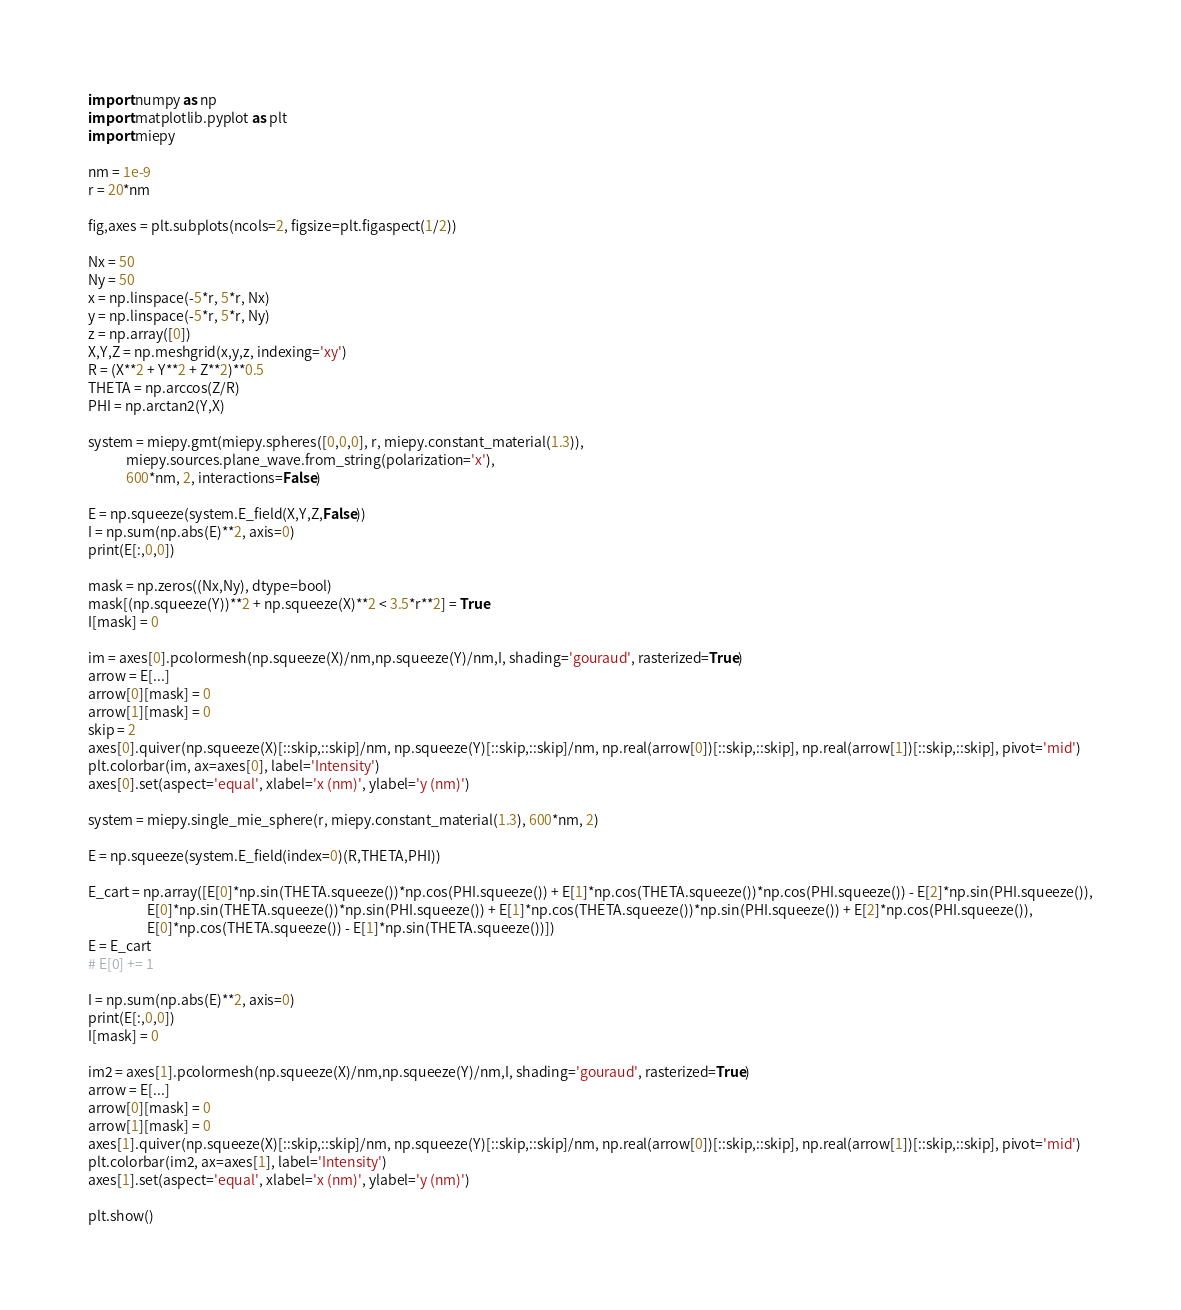<code> <loc_0><loc_0><loc_500><loc_500><_Python_>import numpy as np
import matplotlib.pyplot as plt
import miepy

nm = 1e-9
r = 20*nm

fig,axes = plt.subplots(ncols=2, figsize=plt.figaspect(1/2))

Nx = 50
Ny = 50
x = np.linspace(-5*r, 5*r, Nx)
y = np.linspace(-5*r, 5*r, Ny)
z = np.array([0])
X,Y,Z = np.meshgrid(x,y,z, indexing='xy') 
R = (X**2 + Y**2 + Z**2)**0.5
THETA = np.arccos(Z/R)
PHI = np.arctan2(Y,X)

system = miepy.gmt(miepy.spheres([0,0,0], r, miepy.constant_material(1.3)), 
            miepy.sources.plane_wave.from_string(polarization='x'),
            600*nm, 2, interactions=False)

E = np.squeeze(system.E_field(X,Y,Z,False))
I = np.sum(np.abs(E)**2, axis=0)
print(E[:,0,0])

mask = np.zeros((Nx,Ny), dtype=bool)
mask[(np.squeeze(Y))**2 + np.squeeze(X)**2 < 3.5*r**2] = True
I[mask] = 0

im = axes[0].pcolormesh(np.squeeze(X)/nm,np.squeeze(Y)/nm,I, shading='gouraud', rasterized=True)
arrow = E[...]
arrow[0][mask] = 0
arrow[1][mask] = 0
skip = 2
axes[0].quiver(np.squeeze(X)[::skip,::skip]/nm, np.squeeze(Y)[::skip,::skip]/nm, np.real(arrow[0])[::skip,::skip], np.real(arrow[1])[::skip,::skip], pivot='mid')
plt.colorbar(im, ax=axes[0], label='Intensity')
axes[0].set(aspect='equal', xlabel='x (nm)', ylabel='y (nm)')

system = miepy.single_mie_sphere(r, miepy.constant_material(1.3), 600*nm, 2)

E = np.squeeze(system.E_field(index=0)(R,THETA,PHI))

E_cart = np.array([E[0]*np.sin(THETA.squeeze())*np.cos(PHI.squeeze()) + E[1]*np.cos(THETA.squeeze())*np.cos(PHI.squeeze()) - E[2]*np.sin(PHI.squeeze()),
                   E[0]*np.sin(THETA.squeeze())*np.sin(PHI.squeeze()) + E[1]*np.cos(THETA.squeeze())*np.sin(PHI.squeeze()) + E[2]*np.cos(PHI.squeeze()),
                   E[0]*np.cos(THETA.squeeze()) - E[1]*np.sin(THETA.squeeze())])
E = E_cart
# E[0] += 1

I = np.sum(np.abs(E)**2, axis=0)
print(E[:,0,0])
I[mask] = 0

im2 = axes[1].pcolormesh(np.squeeze(X)/nm,np.squeeze(Y)/nm,I, shading='gouraud', rasterized=True)
arrow = E[...]
arrow[0][mask] = 0
arrow[1][mask] = 0
axes[1].quiver(np.squeeze(X)[::skip,::skip]/nm, np.squeeze(Y)[::skip,::skip]/nm, np.real(arrow[0])[::skip,::skip], np.real(arrow[1])[::skip,::skip], pivot='mid')
plt.colorbar(im2, ax=axes[1], label='Intensity')
axes[1].set(aspect='equal', xlabel='x (nm)', ylabel='y (nm)')

plt.show()
</code> 